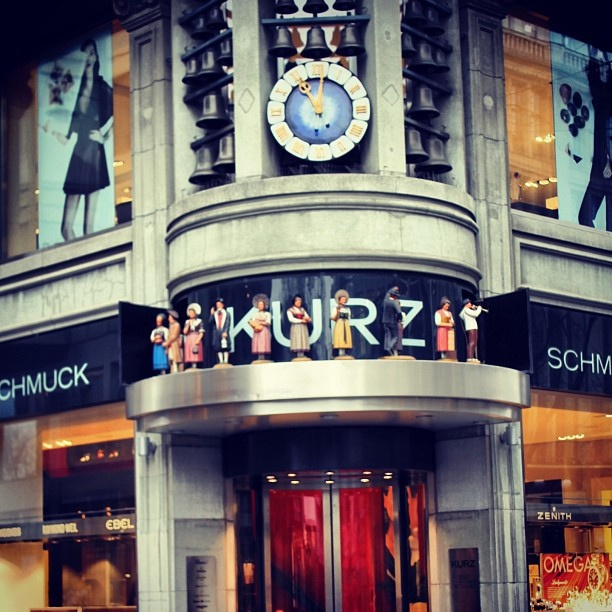Describe the objects in this image and their specific colors. I can see clock in black, beige, khaki, darkgray, and gray tones, people in black, navy, and gray tones, people in black, navy, beige, and gray tones, people in black, tan, darkgray, and gray tones, and people in black, lightpink, tan, gray, and beige tones in this image. 